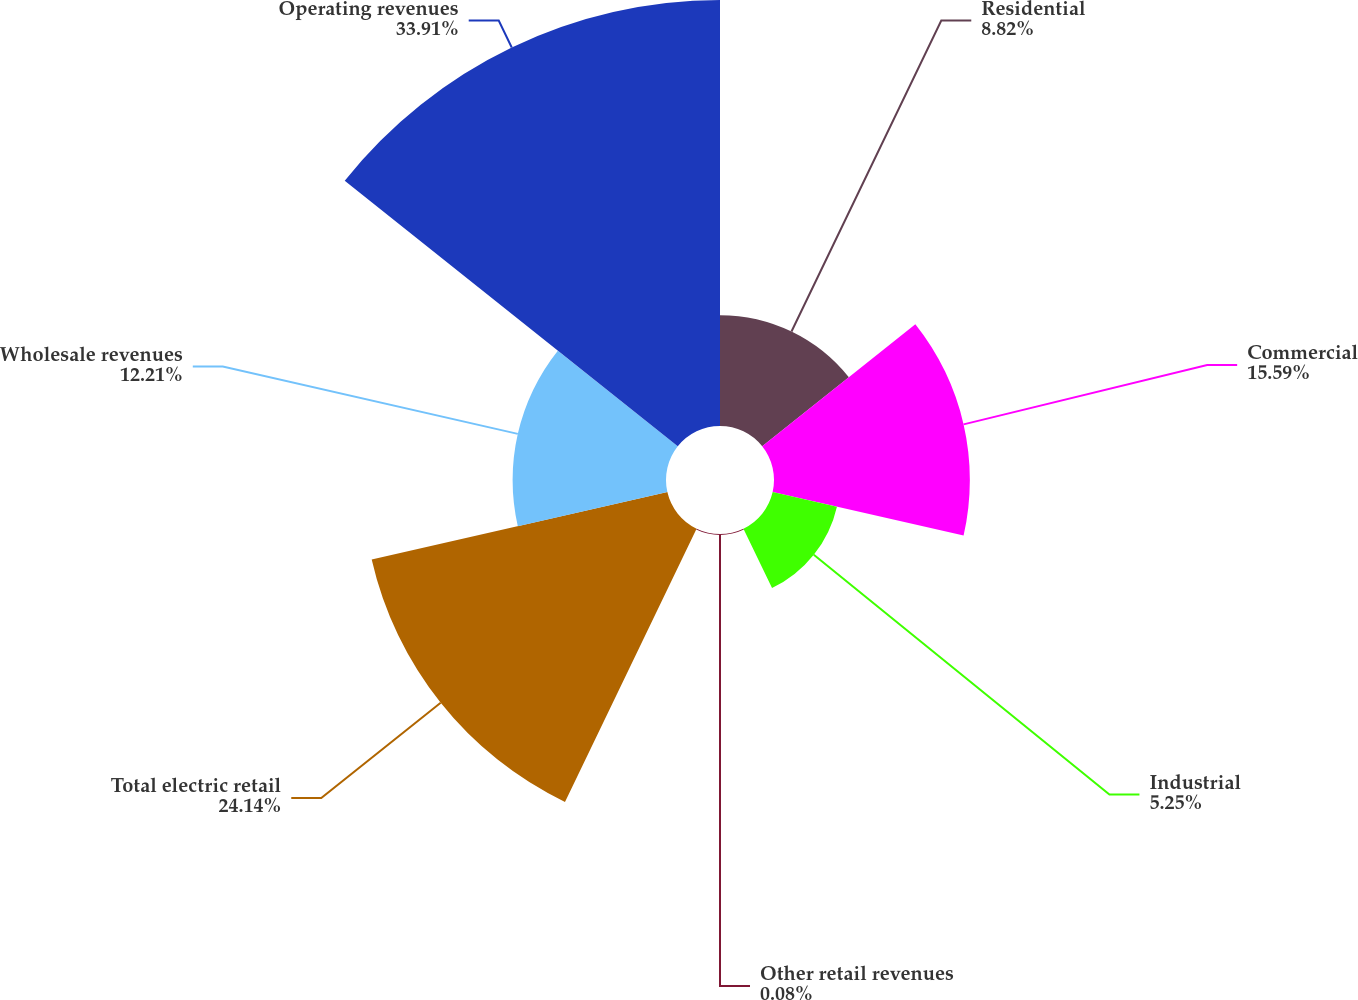Convert chart to OTSL. <chart><loc_0><loc_0><loc_500><loc_500><pie_chart><fcel>Residential<fcel>Commercial<fcel>Industrial<fcel>Other retail revenues<fcel>Total electric retail<fcel>Wholesale revenues<fcel>Operating revenues<nl><fcel>8.82%<fcel>15.59%<fcel>5.25%<fcel>0.08%<fcel>24.14%<fcel>12.21%<fcel>33.91%<nl></chart> 